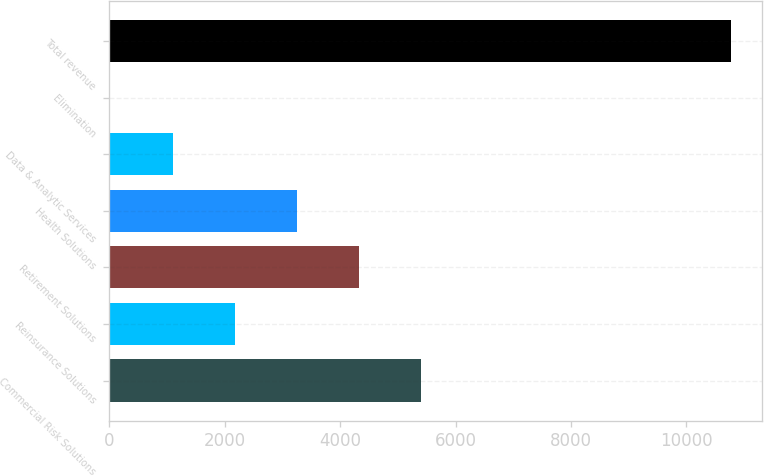<chart> <loc_0><loc_0><loc_500><loc_500><bar_chart><fcel>Commercial Risk Solutions<fcel>Reinsurance Solutions<fcel>Retirement Solutions<fcel>Health Solutions<fcel>Data & Analytic Services<fcel>Elimination<fcel>Total revenue<nl><fcel>5408.6<fcel>2180.9<fcel>4332.7<fcel>3256.8<fcel>1105<fcel>11<fcel>10770<nl></chart> 